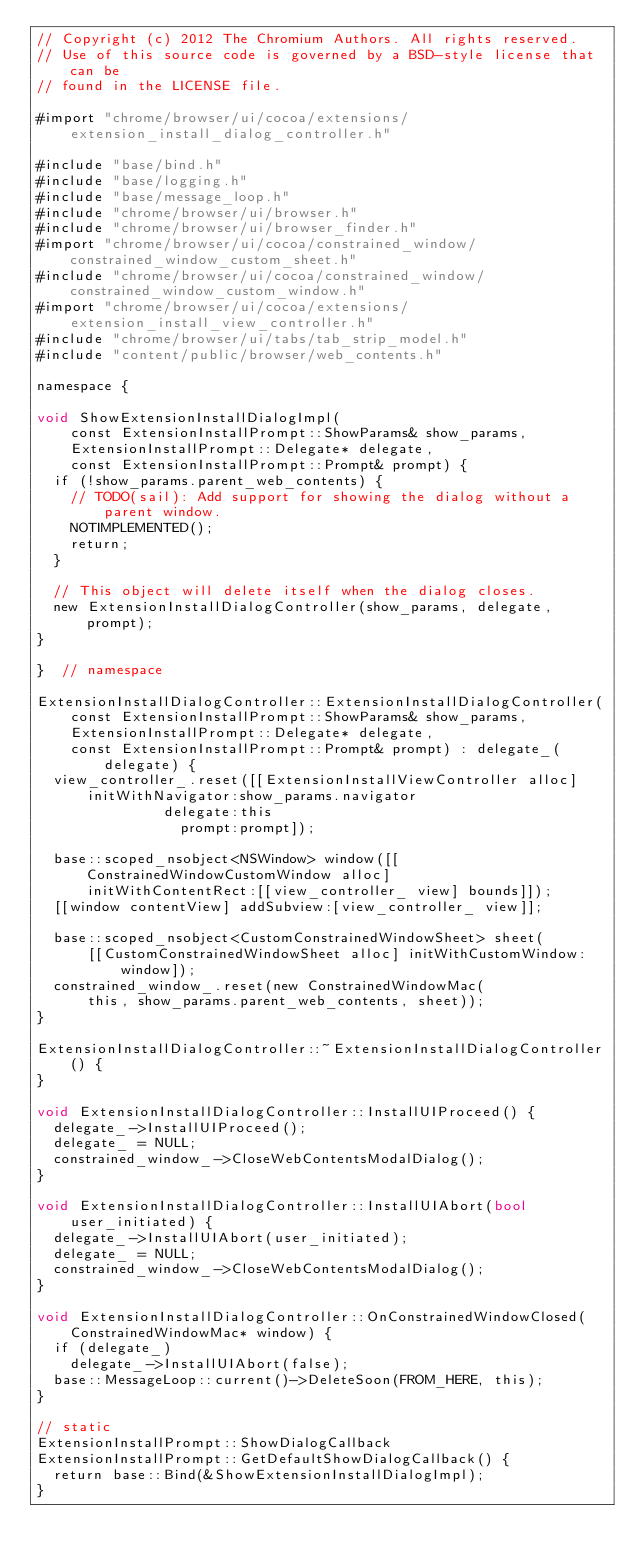Convert code to text. <code><loc_0><loc_0><loc_500><loc_500><_ObjectiveC_>// Copyright (c) 2012 The Chromium Authors. All rights reserved.
// Use of this source code is governed by a BSD-style license that can be
// found in the LICENSE file.

#import "chrome/browser/ui/cocoa/extensions/extension_install_dialog_controller.h"

#include "base/bind.h"
#include "base/logging.h"
#include "base/message_loop.h"
#include "chrome/browser/ui/browser.h"
#include "chrome/browser/ui/browser_finder.h"
#import "chrome/browser/ui/cocoa/constrained_window/constrained_window_custom_sheet.h"
#include "chrome/browser/ui/cocoa/constrained_window/constrained_window_custom_window.h"
#import "chrome/browser/ui/cocoa/extensions/extension_install_view_controller.h"
#include "chrome/browser/ui/tabs/tab_strip_model.h"
#include "content/public/browser/web_contents.h"

namespace {

void ShowExtensionInstallDialogImpl(
    const ExtensionInstallPrompt::ShowParams& show_params,
    ExtensionInstallPrompt::Delegate* delegate,
    const ExtensionInstallPrompt::Prompt& prompt) {
  if (!show_params.parent_web_contents) {
    // TODO(sail): Add support for showing the dialog without a parent window.
    NOTIMPLEMENTED();
    return;
  }

  // This object will delete itself when the dialog closes.
  new ExtensionInstallDialogController(show_params, delegate, prompt);
}

}  // namespace

ExtensionInstallDialogController::ExtensionInstallDialogController(
    const ExtensionInstallPrompt::ShowParams& show_params,
    ExtensionInstallPrompt::Delegate* delegate,
    const ExtensionInstallPrompt::Prompt& prompt) : delegate_(delegate) {
  view_controller_.reset([[ExtensionInstallViewController alloc]
      initWithNavigator:show_params.navigator
               delegate:this
                 prompt:prompt]);

  base::scoped_nsobject<NSWindow> window([[ConstrainedWindowCustomWindow alloc]
      initWithContentRect:[[view_controller_ view] bounds]]);
  [[window contentView] addSubview:[view_controller_ view]];

  base::scoped_nsobject<CustomConstrainedWindowSheet> sheet(
      [[CustomConstrainedWindowSheet alloc] initWithCustomWindow:window]);
  constrained_window_.reset(new ConstrainedWindowMac(
      this, show_params.parent_web_contents, sheet));
}

ExtensionInstallDialogController::~ExtensionInstallDialogController() {
}

void ExtensionInstallDialogController::InstallUIProceed() {
  delegate_->InstallUIProceed();
  delegate_ = NULL;
  constrained_window_->CloseWebContentsModalDialog();
}

void ExtensionInstallDialogController::InstallUIAbort(bool user_initiated) {
  delegate_->InstallUIAbort(user_initiated);
  delegate_ = NULL;
  constrained_window_->CloseWebContentsModalDialog();
}

void ExtensionInstallDialogController::OnConstrainedWindowClosed(
    ConstrainedWindowMac* window) {
  if (delegate_)
    delegate_->InstallUIAbort(false);
  base::MessageLoop::current()->DeleteSoon(FROM_HERE, this);
}

// static
ExtensionInstallPrompt::ShowDialogCallback
ExtensionInstallPrompt::GetDefaultShowDialogCallback() {
  return base::Bind(&ShowExtensionInstallDialogImpl);
}
</code> 